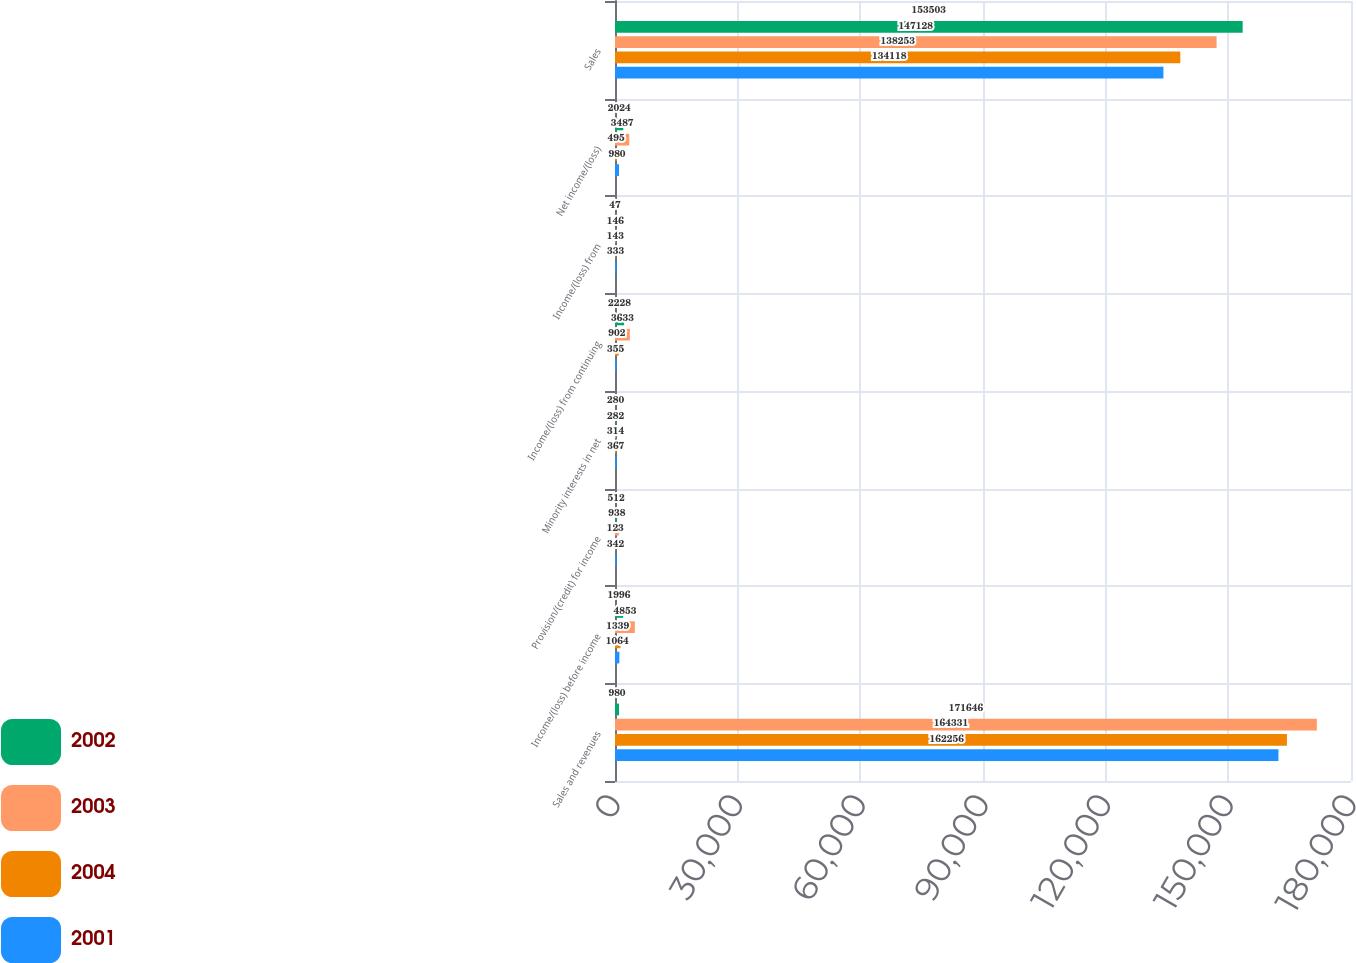<chart> <loc_0><loc_0><loc_500><loc_500><stacked_bar_chart><ecel><fcel>Sales and revenues<fcel>Income/(loss) before income<fcel>Provision/(credit) for income<fcel>Minority interests in net<fcel>Income/(loss) from continuing<fcel>Income/(loss) from<fcel>Net income/(loss)<fcel>Sales<nl><fcel>2002<fcel>980<fcel>1996<fcel>512<fcel>280<fcel>2228<fcel>47<fcel>2024<fcel>153503<nl><fcel>2003<fcel>171646<fcel>4853<fcel>938<fcel>282<fcel>3633<fcel>146<fcel>3487<fcel>147128<nl><fcel>2004<fcel>164331<fcel>1339<fcel>123<fcel>314<fcel>902<fcel>143<fcel>495<fcel>138253<nl><fcel>2001<fcel>162256<fcel>1064<fcel>342<fcel>367<fcel>355<fcel>333<fcel>980<fcel>134118<nl></chart> 